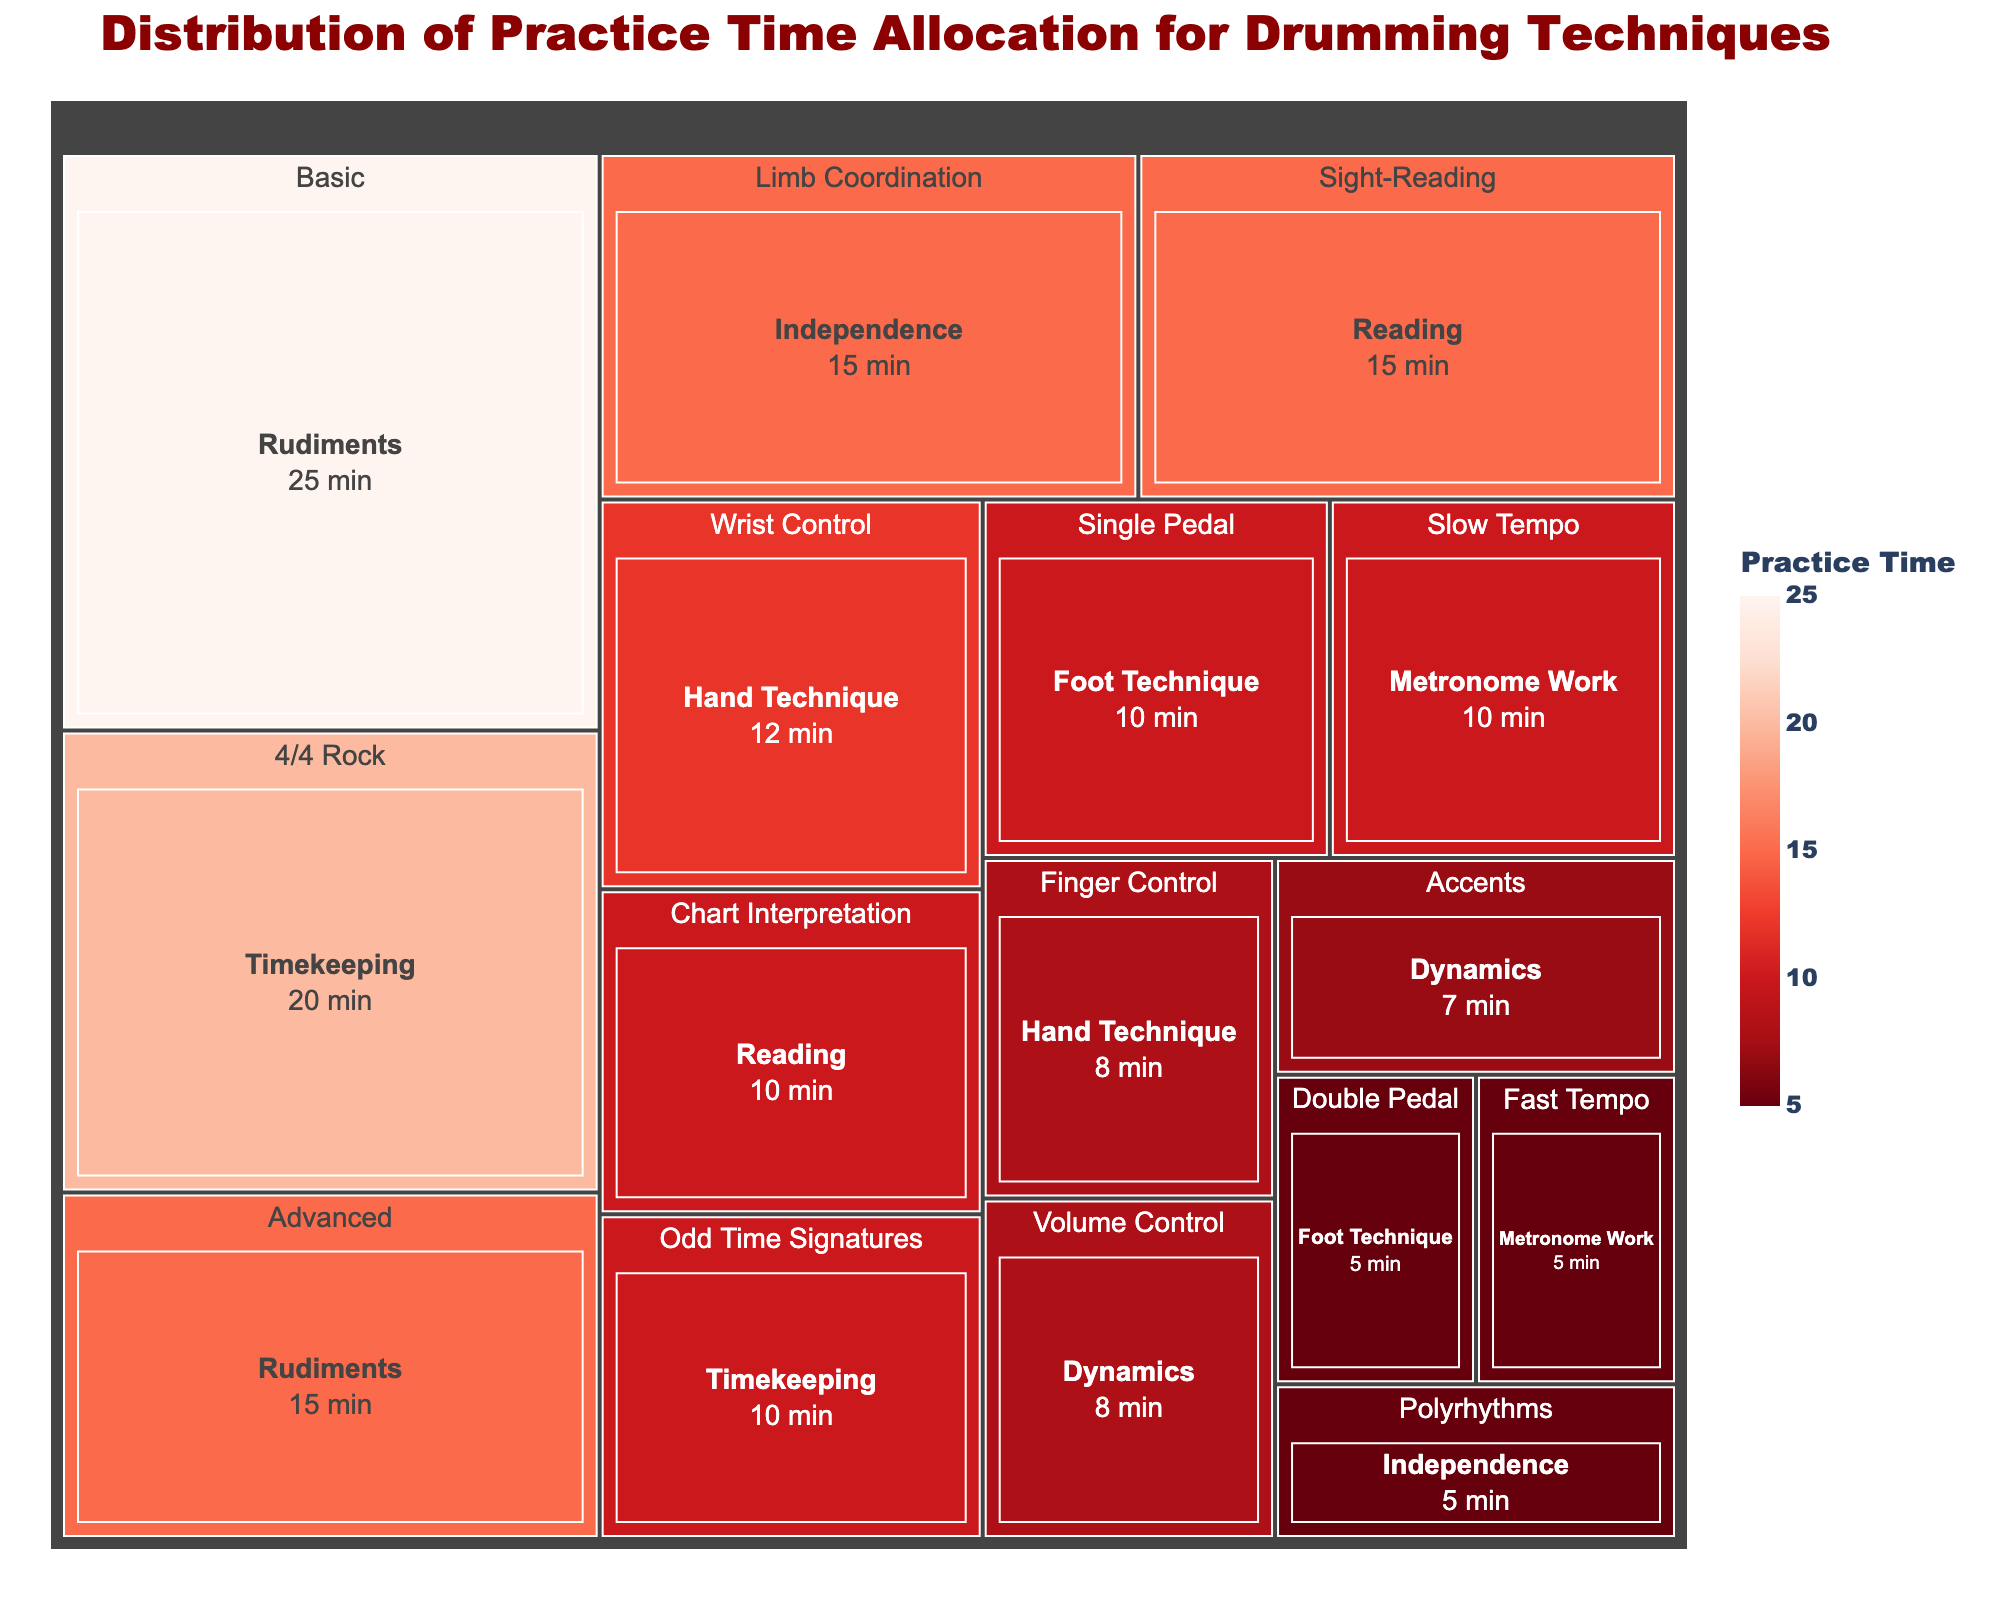What is the title of the treemap? The title is usually displayed prominently at the top of the figure. The title summarizes the entire figure in a few words.
Answer: Distribution of Practice Time Allocation for Drumming Techniques Which technique under 'Rudiments' has more practice time allocated? Under the 'Rudiments' category, compare the 'Basic' and 'Advanced' techniques by looking at their respective areas in the treemap.
Answer: Basic What is the total practice time allocated to 'Timekeeping' techniques? Sum the practice times of '4/4 Rock' (20 minutes) and 'Odd Time Signatures' (10 minutes) under 'Timekeeping'.
Answer: 30 minutes Which category has the smallest allocated practice time? Estimate the smallest area among the categories in the treemap, which indicates the least practice time.
Answer: Dynamics Which technique under 'Independence' has less practice time? Compare the practice times for 'Limb Coordination' (15 minutes) and 'Polyrhythms' (5 minutes) under 'Independence'.
Answer: Polyrhythms How much more practice time is allocated to 'Wrist Control' than 'Finger Control'? Compare the practice times for 'Wrist Control' (12 minutes) and 'Finger Control' (8 minutes) and calculate the difference.
Answer: 4 minutes What is the combined practice time for 'Foot Technique' techniques? Add the practice times for 'Single Pedal' (10 minutes) and 'Double Pedal' (5 minutes) under 'Foot Technique'.
Answer: 15 minutes Which technique within 'Metronome Work' has less practice time? Compare the practice times for 'Slow Tempo' (10 minutes) and 'Fast Tempo' (5 minutes) under 'Metronome Work'.
Answer: Fast Tempo Which category has the largest total practice time? Identify the category with the largest area, which indicates the greatest total practice time.
Answer: Rudiments How does 'Sight-Reading' practice time compare to 'Chart Interpretation'? Compare the practice times for 'Sight-Reading' (15 minutes) and 'Chart Interpretation' (10 minutes) under 'Reading'.
Answer: Sight-Reading has more time 